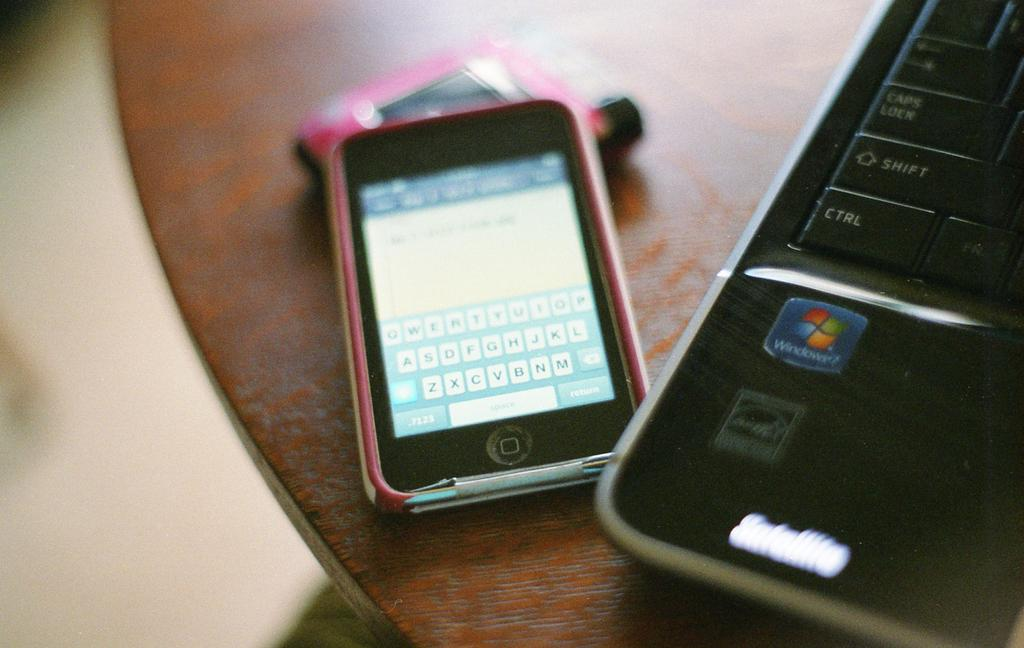<image>
Render a clear and concise summary of the photo. A phone next to a laptop that runs Windows 